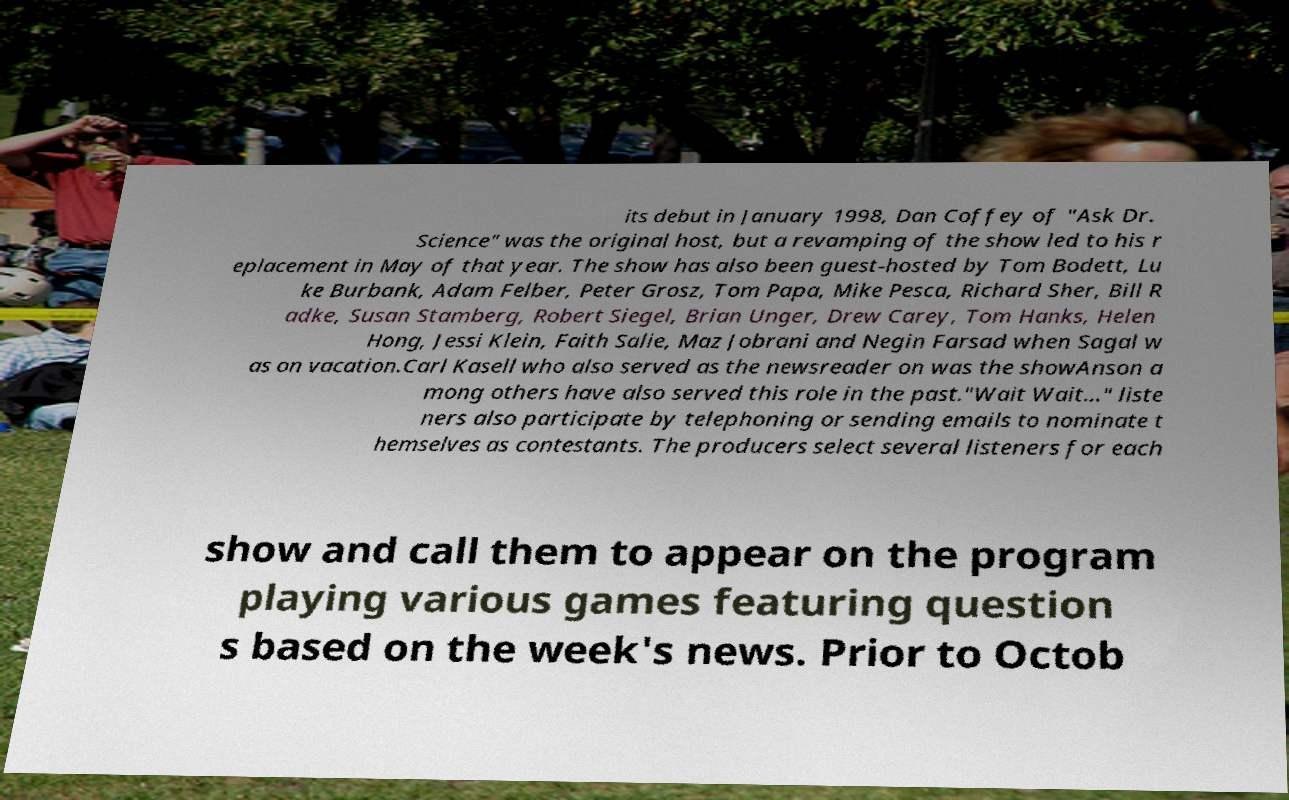Could you extract and type out the text from this image? its debut in January 1998, Dan Coffey of "Ask Dr. Science" was the original host, but a revamping of the show led to his r eplacement in May of that year. The show has also been guest-hosted by Tom Bodett, Lu ke Burbank, Adam Felber, Peter Grosz, Tom Papa, Mike Pesca, Richard Sher, Bill R adke, Susan Stamberg, Robert Siegel, Brian Unger, Drew Carey, Tom Hanks, Helen Hong, Jessi Klein, Faith Salie, Maz Jobrani and Negin Farsad when Sagal w as on vacation.Carl Kasell who also served as the newsreader on was the showAnson a mong others have also served this role in the past."Wait Wait..." liste ners also participate by telephoning or sending emails to nominate t hemselves as contestants. The producers select several listeners for each show and call them to appear on the program playing various games featuring question s based on the week's news. Prior to Octob 